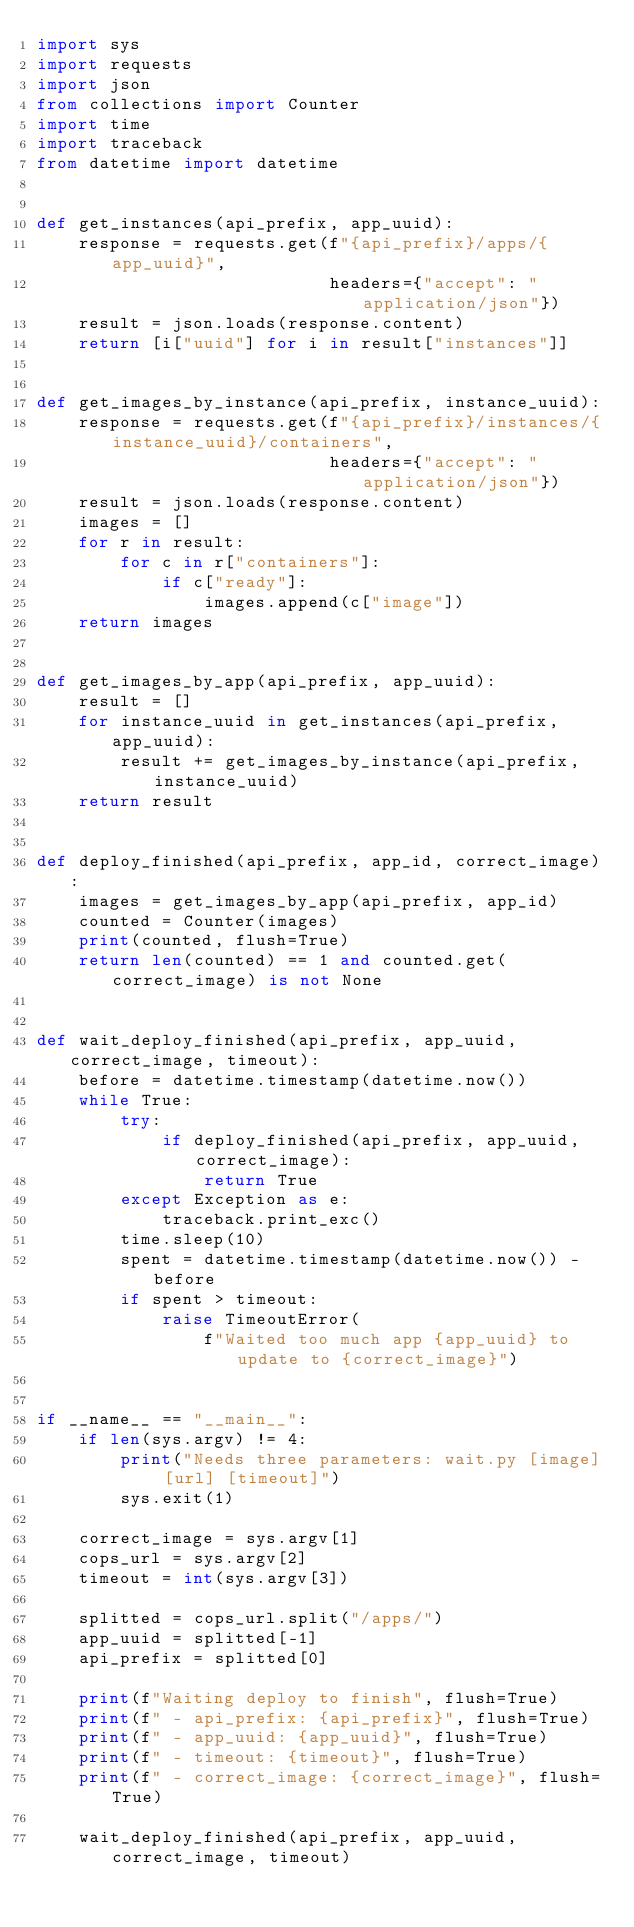<code> <loc_0><loc_0><loc_500><loc_500><_Python_>import sys
import requests
import json
from collections import Counter
import time
import traceback
from datetime import datetime


def get_instances(api_prefix, app_uuid):
    response = requests.get(f"{api_prefix}/apps/{app_uuid}",
                            headers={"accept": "application/json"})
    result = json.loads(response.content)
    return [i["uuid"] for i in result["instances"]]


def get_images_by_instance(api_prefix, instance_uuid):
    response = requests.get(f"{api_prefix}/instances/{instance_uuid}/containers",
                            headers={"accept": "application/json"})
    result = json.loads(response.content)
    images = []
    for r in result:
        for c in r["containers"]:
            if c["ready"]:
                images.append(c["image"])
    return images


def get_images_by_app(api_prefix, app_uuid):
    result = []
    for instance_uuid in get_instances(api_prefix, app_uuid):
        result += get_images_by_instance(api_prefix, instance_uuid)
    return result


def deploy_finished(api_prefix, app_id, correct_image):
    images = get_images_by_app(api_prefix, app_id)
    counted = Counter(images)
    print(counted, flush=True)
    return len(counted) == 1 and counted.get(correct_image) is not None


def wait_deploy_finished(api_prefix, app_uuid, correct_image, timeout):
    before = datetime.timestamp(datetime.now())
    while True:
        try:
            if deploy_finished(api_prefix, app_uuid, correct_image):
                return True
        except Exception as e:
            traceback.print_exc()
        time.sleep(10)
        spent = datetime.timestamp(datetime.now()) - before
        if spent > timeout:
            raise TimeoutError(
                f"Waited too much app {app_uuid} to update to {correct_image}")


if __name__ == "__main__":
    if len(sys.argv) != 4:
        print("Needs three parameters: wait.py [image] [url] [timeout]")
        sys.exit(1)

    correct_image = sys.argv[1]
    cops_url = sys.argv[2]
    timeout = int(sys.argv[3])

    splitted = cops_url.split("/apps/")
    app_uuid = splitted[-1]
    api_prefix = splitted[0]

    print(f"Waiting deploy to finish", flush=True)
    print(f" - api_prefix: {api_prefix}", flush=True)
    print(f" - app_uuid: {app_uuid}", flush=True)
    print(f" - timeout: {timeout}", flush=True)
    print(f" - correct_image: {correct_image}", flush=True)

    wait_deploy_finished(api_prefix, app_uuid, correct_image, timeout)
</code> 